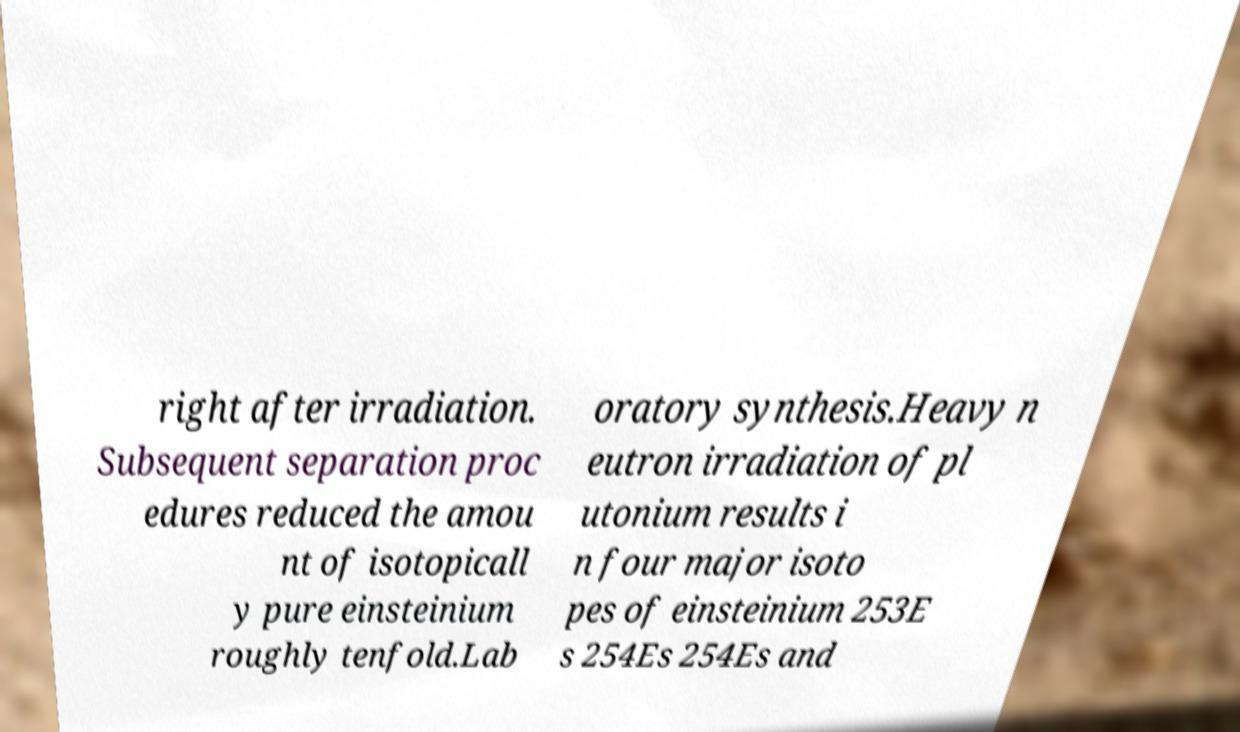What messages or text are displayed in this image? I need them in a readable, typed format. right after irradiation. Subsequent separation proc edures reduced the amou nt of isotopicall y pure einsteinium roughly tenfold.Lab oratory synthesis.Heavy n eutron irradiation of pl utonium results i n four major isoto pes of einsteinium 253E s 254Es 254Es and 